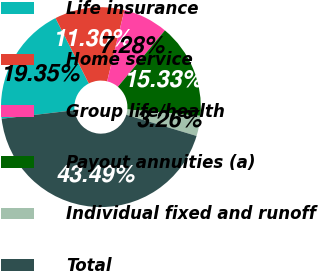<chart> <loc_0><loc_0><loc_500><loc_500><pie_chart><fcel>Life insurance<fcel>Home service<fcel>Group life/health<fcel>Payout annuities (a)<fcel>Individual fixed and runoff<fcel>Total<nl><fcel>19.35%<fcel>11.3%<fcel>7.28%<fcel>15.33%<fcel>3.26%<fcel>43.49%<nl></chart> 